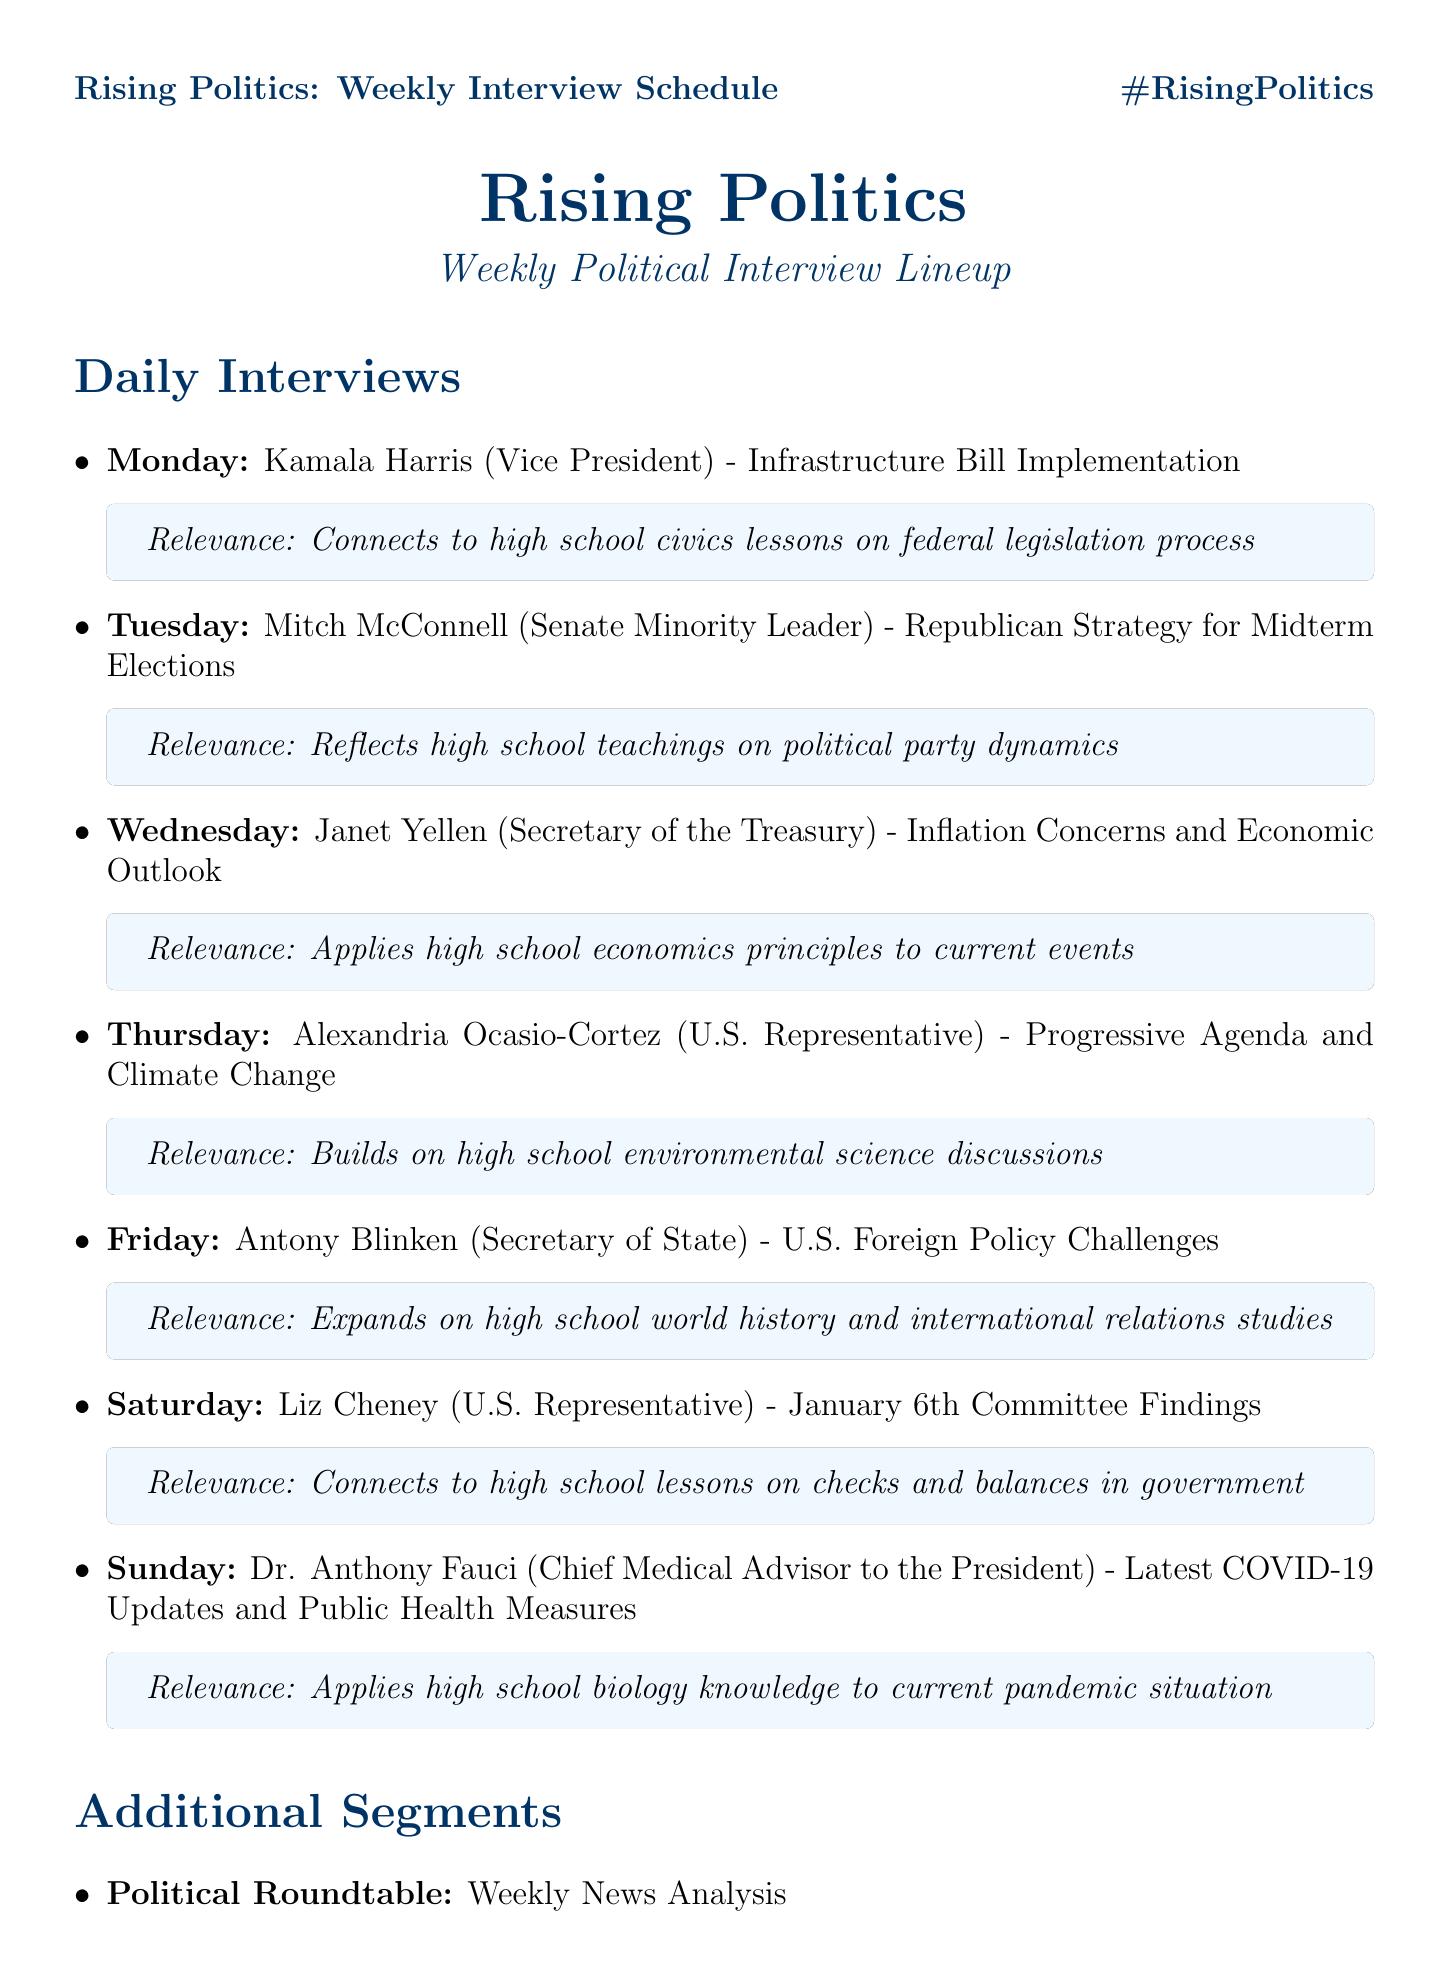What day is Kamala Harris scheduled? The document indicates that Kamala Harris is scheduled on Monday.
Answer: Monday What is the main topic discussed with Mitch McConnell? The document states that the main topic for Mitch McConnell is the Republican Strategy for Midterm Elections.
Answer: Republican Strategy for Midterm Elections Who is the Chief Medical Advisor to the President? The document identifies Dr. Anthony Fauci as the Chief Medical Advisor to the President.
Answer: Dr. Anthony Fauci Which guest's topic relates to high school economics? The document mentions Janet Yellen discussing Inflation Concerns and Economic Outlook, which relates to high school economics.
Answer: Janet Yellen What is the broadcast time of the weekly interview schedule? According to the document, the broadcast time is specified as 8:00 PM ET.
Answer: 8:00 PM ET Which segment includes Doris Kearns Goodwin? The document highlights that the Historical Context segment features Doris Kearns Goodwin as the expert.
Answer: Historical Context What topic is covered on Saturday? The document outlines that on Saturday, Liz Cheney discusses the January 6th Committee Findings.
Answer: January 6th Committee Findings How many days are covered in the weekly interview lineup? The document lists interviews for each day from Monday to Sunday, totaling seven days.
Answer: Seven days What is the social media hashtag associated with this lineup? The document specifies that the social media hashtag is #RisingPolitics.
Answer: #RisingPolitics 